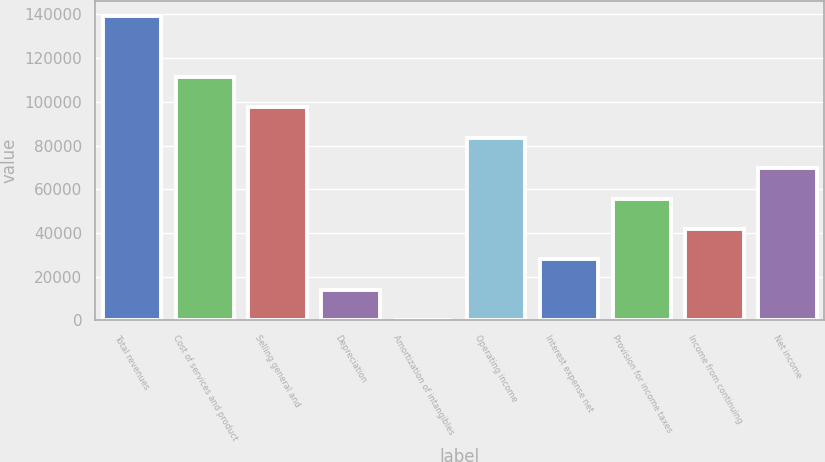<chart> <loc_0><loc_0><loc_500><loc_500><bar_chart><fcel>Total revenues<fcel>Cost of services and product<fcel>Selling general and<fcel>Depreciation<fcel>Amortization of intangibles<fcel>Operating income<fcel>Interest expense net<fcel>Provision for income taxes<fcel>Income from continuing<fcel>Net income<nl><fcel>139265<fcel>111416<fcel>97491.8<fcel>13945.4<fcel>21<fcel>83567.4<fcel>27869.8<fcel>55718.6<fcel>41794.2<fcel>69643<nl></chart> 